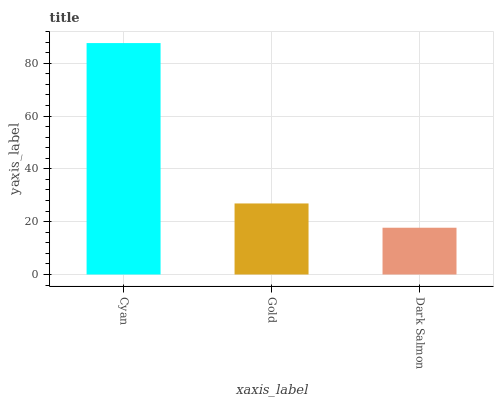Is Dark Salmon the minimum?
Answer yes or no. Yes. Is Cyan the maximum?
Answer yes or no. Yes. Is Gold the minimum?
Answer yes or no. No. Is Gold the maximum?
Answer yes or no. No. Is Cyan greater than Gold?
Answer yes or no. Yes. Is Gold less than Cyan?
Answer yes or no. Yes. Is Gold greater than Cyan?
Answer yes or no. No. Is Cyan less than Gold?
Answer yes or no. No. Is Gold the high median?
Answer yes or no. Yes. Is Gold the low median?
Answer yes or no. Yes. Is Cyan the high median?
Answer yes or no. No. Is Cyan the low median?
Answer yes or no. No. 